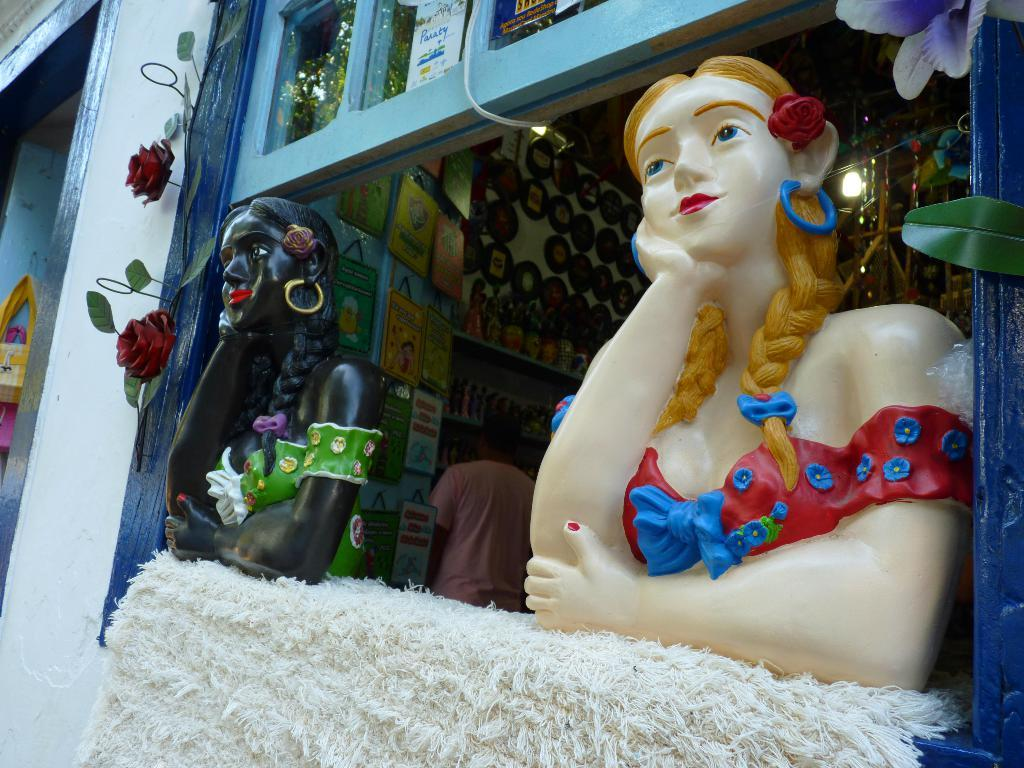What type of objects can be seen in the image? There are statues and flowers in the image. Can you describe the background of the image? In the background of the image, there are a person, boards, and toys. How many statues are visible in the image? The number of statues is not specified, but there are at least two statues visible. What might the boards in the background be used for? The boards in the background could be used for various purposes, such as signage or displaying information. What type of screw can be seen in the image? There is no screw present in the image. How many women are visible in the image? There is no mention of women in the image; only a person is mentioned in the background. 